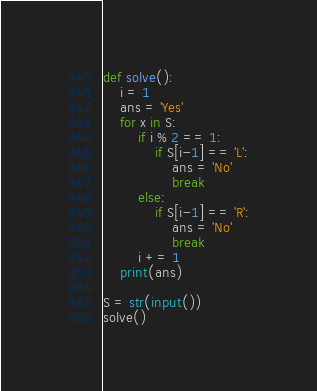Convert code to text. <code><loc_0><loc_0><loc_500><loc_500><_Python_>def solve():
    i = 1
    ans = 'Yes'
    for x in S:
        if i % 2 == 1:
            if S[i-1] == 'L':
                ans = 'No'
                break
        else:
            if S[i-1] == 'R':
                ans = 'No'
                break
        i += 1
    print(ans)

S = str(input())
solve()</code> 